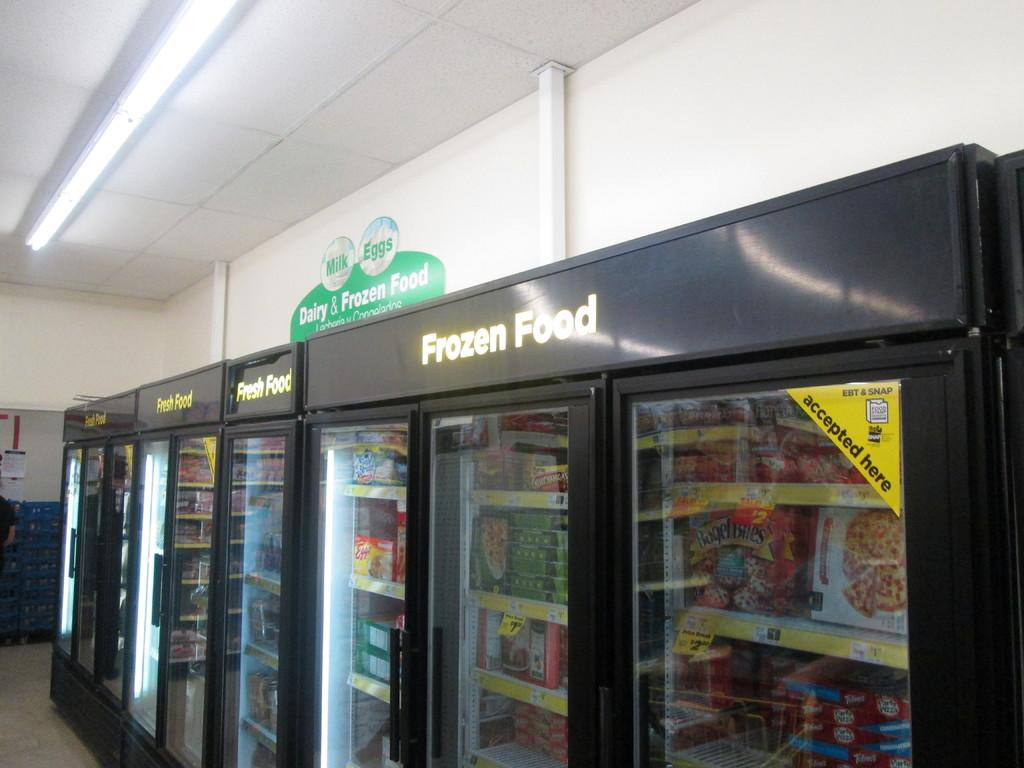<image>
Write a terse but informative summary of the picture. Dairy and Frozen Food section of a store. 